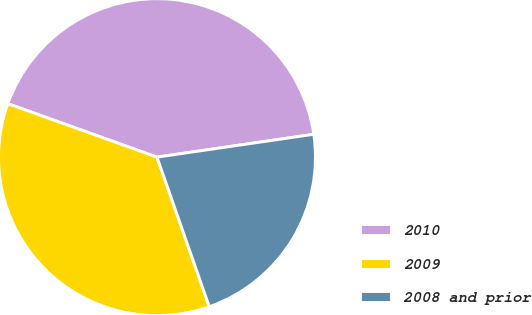Convert chart to OTSL. <chart><loc_0><loc_0><loc_500><loc_500><pie_chart><fcel>2010<fcel>2009<fcel>2008 and prior<nl><fcel>42.22%<fcel>35.83%<fcel>21.95%<nl></chart> 